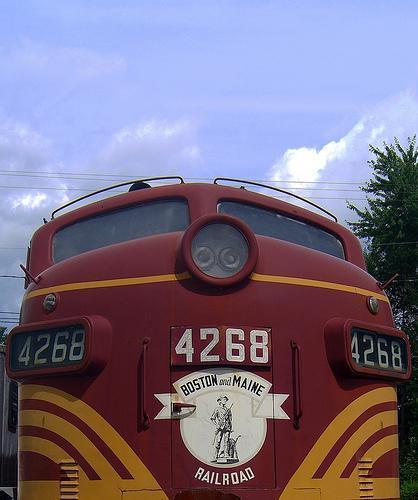How many trains are there?
Give a very brief answer. 1. 